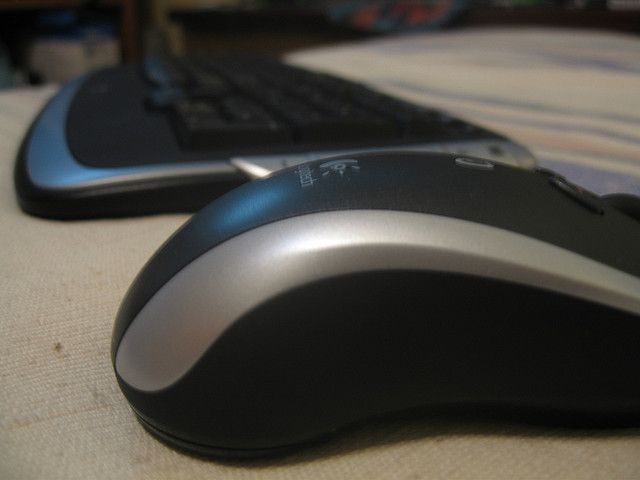<image>What kind of fruit is on the mouse? There is no fruit on the mouse. Is the mouse wireless? I am not sure if the mouse is wireless. However, it is mostly seen as wireless. What kind of fruit is on the mouse? There is no fruit on the mouse. Is the mouse wireless? I don't know if the mouse is wireless. It is possible that it is wireless. 